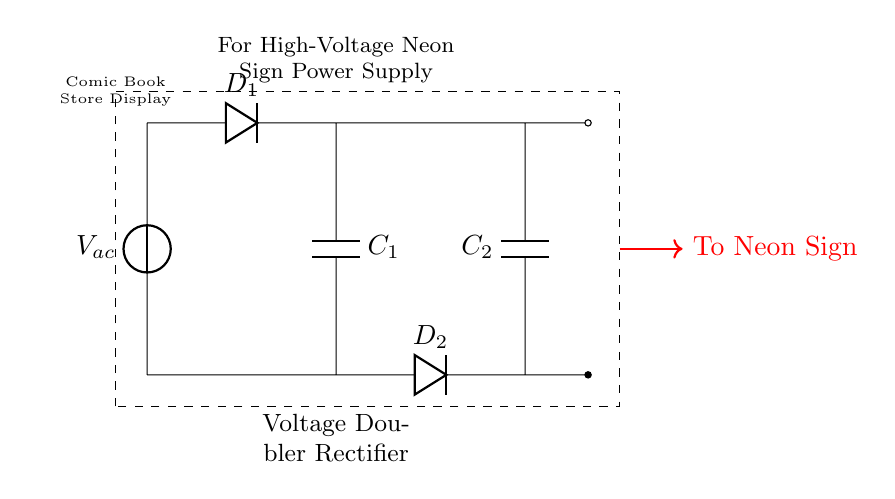What type of circuit is depicted? The circuit is a voltage doubler rectifier, designed to increase the voltage from an AC source. This is indicated by the arrangement of two diodes and capacitors, as well as the labeling within the diagram.
Answer: voltage doubler rectifier How many diodes are used in this circuit? The circuit diagram clearly shows two diodes labeled D1 and D2. Counting these components directly from the drawing indicates their number.
Answer: 2 diodes What is the purpose of the capacitors in this circuit? The capacitors C1 and C2 are used for smoothing and energy storage. They charge during the positive half-cycle of the AC input and discharge to the load during the negative half-cycle, effectively doubling the voltage output.
Answer: smoothing and energy storage What voltage does the circuit output to the neon sign? The circuit diagram indicates that the output is designed for high-voltage applications, specifically stated in the caption directing power to the neon sign. While an exact voltage is not specified, the context implies a high-voltage output suitable for neon signs, typically in the range of several thousand volts.
Answer: high voltage How is the circuit connected to the neon sign? The diagram shows a connection from the output terminals to the neon sign, which is indicated by a red arrow labeled "To Neon Sign." This highlights the direct path for the electrification of the sign.
Answer: direct connection What does component C2 do in this circuit? C2, like C1, acts as a storage element that charges and discharges to the neon sign during operation, enhancing the voltage output and ensuring a steady current. This is derived from its similar placement and role in the arrangement.
Answer: voltage doubling 